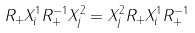<formula> <loc_0><loc_0><loc_500><loc_500>R _ { + } X _ { i } ^ { 1 } R _ { + } ^ { - 1 } X _ { j } ^ { 2 } = X _ { j } ^ { 2 } R _ { + } X _ { i } ^ { 1 } R _ { + } ^ { - 1 }</formula> 